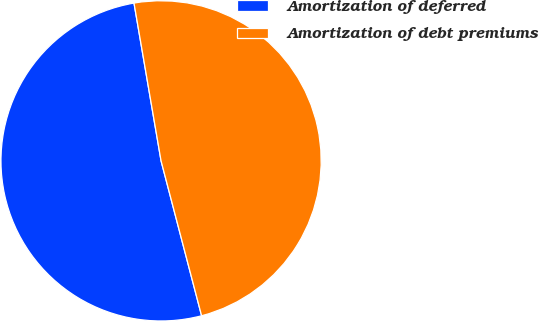<chart> <loc_0><loc_0><loc_500><loc_500><pie_chart><fcel>Amortization of deferred<fcel>Amortization of debt premiums<nl><fcel>51.37%<fcel>48.63%<nl></chart> 